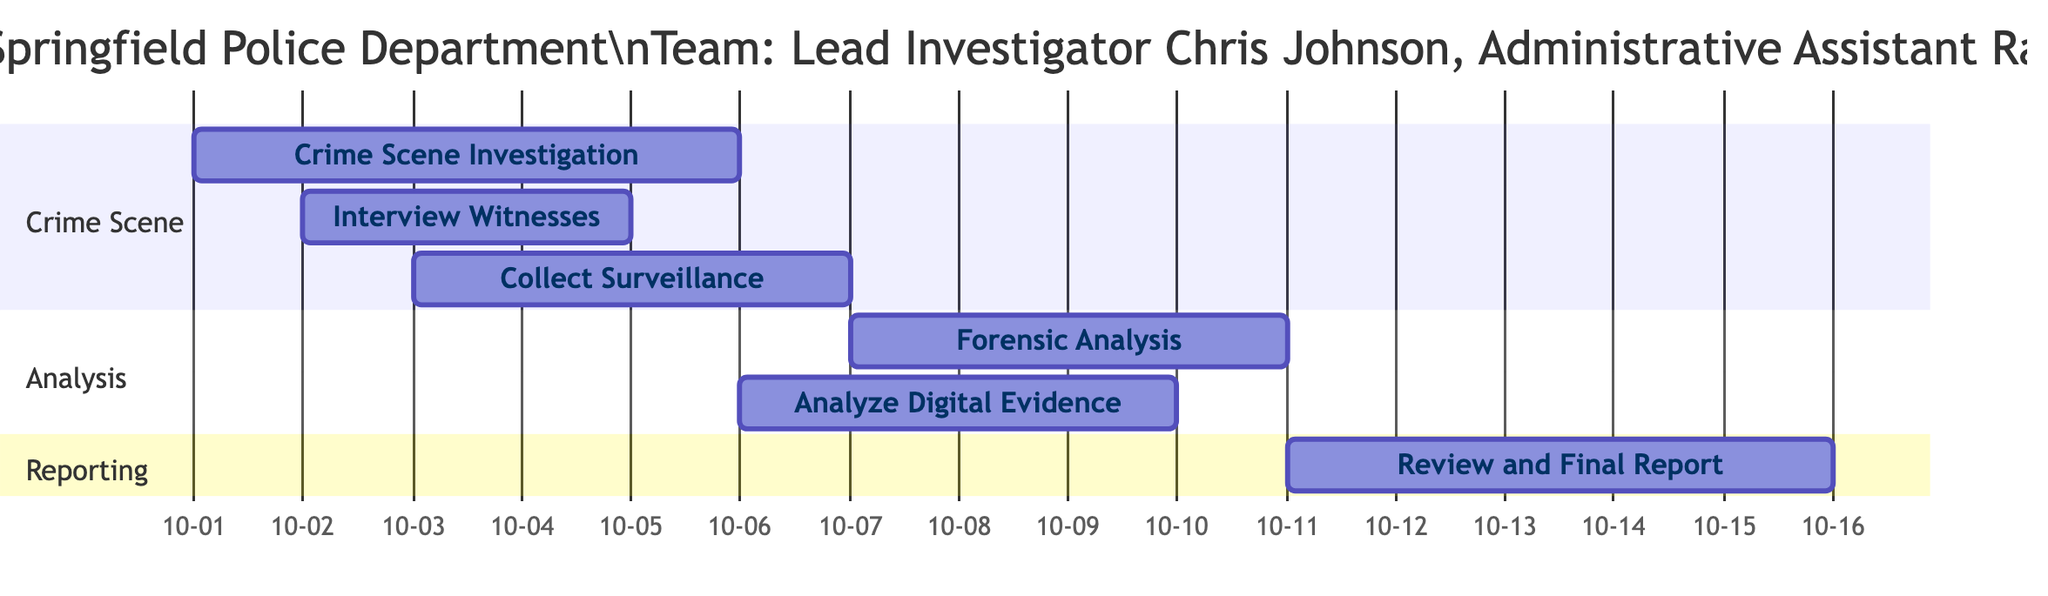What is the start date of the Crime Scene Investigation? The start date for the task labeled "Crime Scene Investigation" in the diagram is indicated as 2023-10-01.
Answer: 2023-10-01 What are the assigned team members for the "Forensic Analysis"? The task "Forensic Analysis" has team members listed as "Forensic Expert David Lee" and "Lab Technician Anna Brown".
Answer: Forensic Expert David Lee, Lab Technician Anna Brown How many tasks are scheduled to start on October 3rd? Referring to the diagram, there are two tasks starting on October 3rd: "Collect Surveillance Footage" and "Interview Witnesses".
Answer: 2 Which task occurs latest in the schedule? Upon examining the end dates of all tasks, the latest task is "Review Case and Compile Final Report" which ends on 2023-10-15.
Answer: Review Case and Compile Final Report What is the overlap between "Collect Surveillance Footage" and "Analyze Digital Evidence"? The task "Collect Surveillance Footage" starts on October 3rd and ends on October 6th, while "Analyze Digital Evidence" starts on October 6th and ends on October 9th. The overlap occurs on October 6th.
Answer: October 6th Which location has the most tasks assigned to it? By reviewing the locations for each task, "Springfield Police Department" is tied with two tasks: "Interview Witnesses" and "Review Case and Compile Final Report".
Answer: Springfield Police Department How many days does the "Crime Scene Investigation" take? The duration of "Crime Scene Investigation" is calculated from its start date on October 1st to its end date on October 5th, giving a total of 5 days.
Answer: 5 days Which task has the least number of assigned team members? By checking tasks, both "Forensic Analysis" and "Review Case and Compile Final Report" have two assigned team members, which is the lowest count among all tasks listed.
Answer: Forensic Analysis, Review Case and Compile Final Report What day does "Analyze Digital Evidence" start? The diagram shows that "Analyze Digital Evidence" begins on October 6th.
Answer: October 6th 